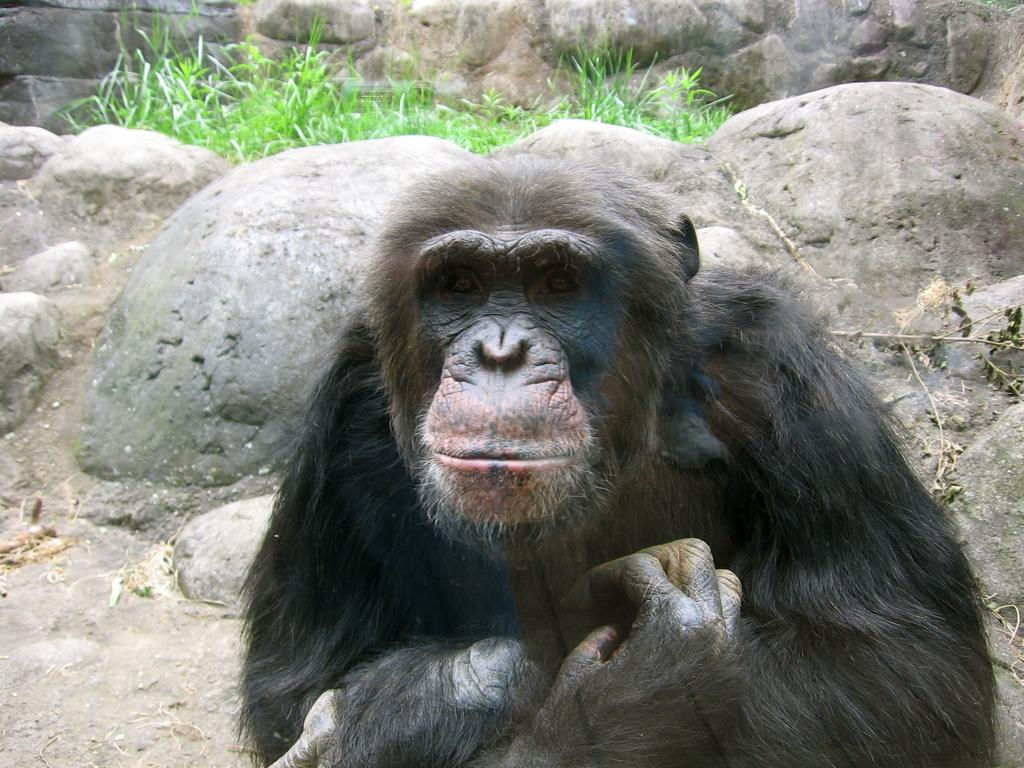What is the main subject in the center of the image? There is a chimpanzee in the center of the image. What can be seen in the background of the image? There are rocks and grass in the background of the image. What is visible at the bottom of the image? There is ground visible at the bottom of the image. What type of face can be seen on the thing in the image? There is no "thing" with a face present in the image; the main subject is a chimpanzee. Is there a beggar visible in the image? There is no beggar present in the image; the main subject is a chimpanzee. 